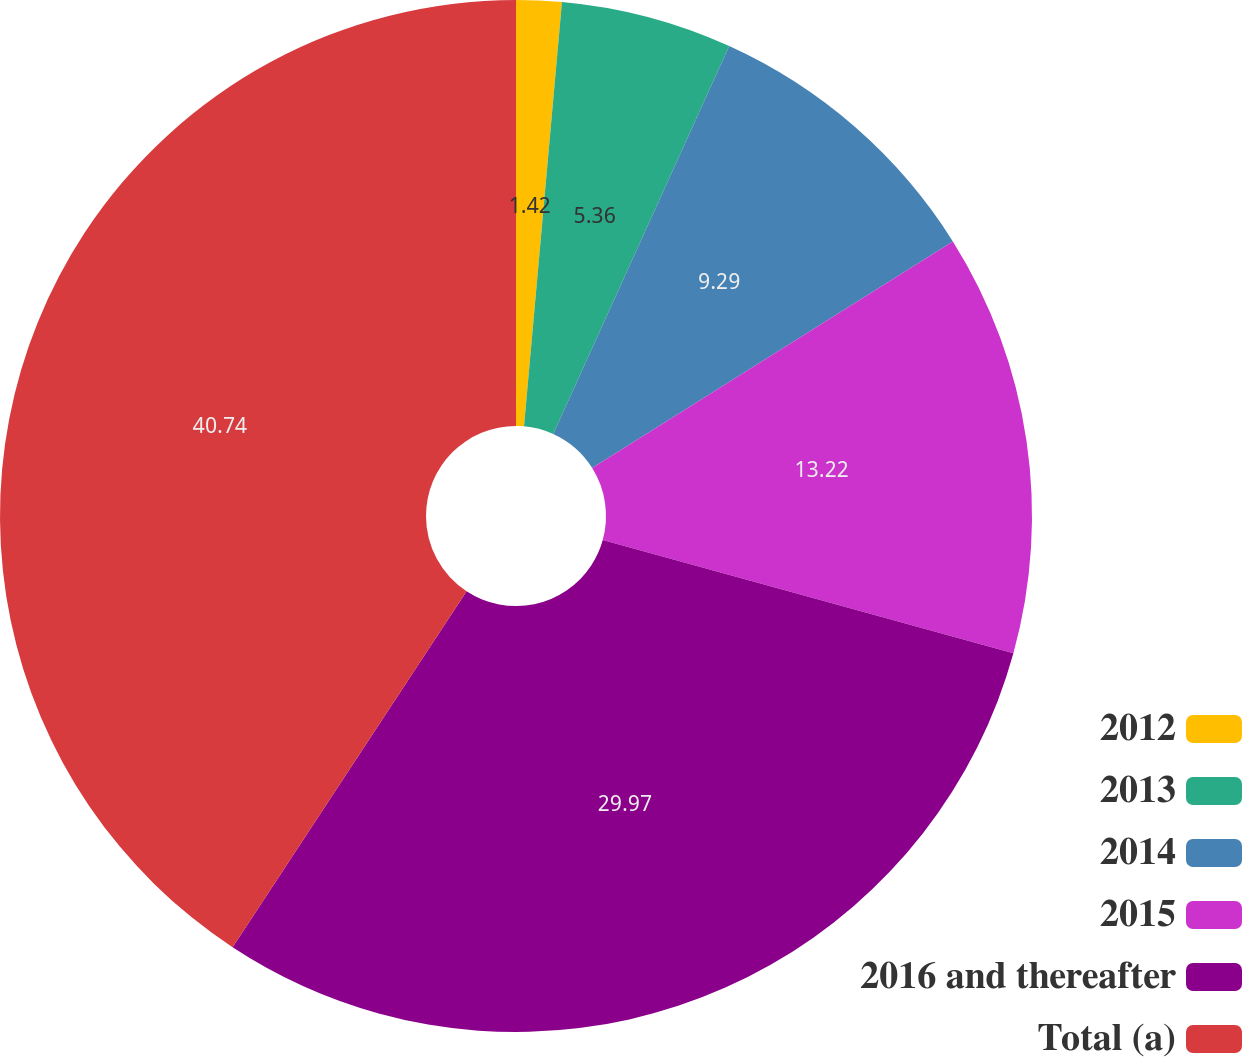<chart> <loc_0><loc_0><loc_500><loc_500><pie_chart><fcel>2012<fcel>2013<fcel>2014<fcel>2015<fcel>2016 and thereafter<fcel>Total (a)<nl><fcel>1.42%<fcel>5.36%<fcel>9.29%<fcel>13.22%<fcel>29.97%<fcel>40.75%<nl></chart> 